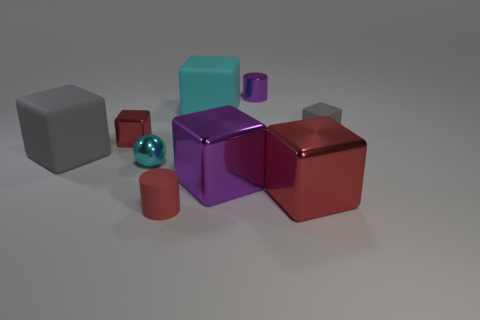Which one is the smallest object and what does it look like? The smallest object in the image is the sphere, which has a reflective surface that's somewhat like a mirror, primarily reflecting the environment and objects around it. 